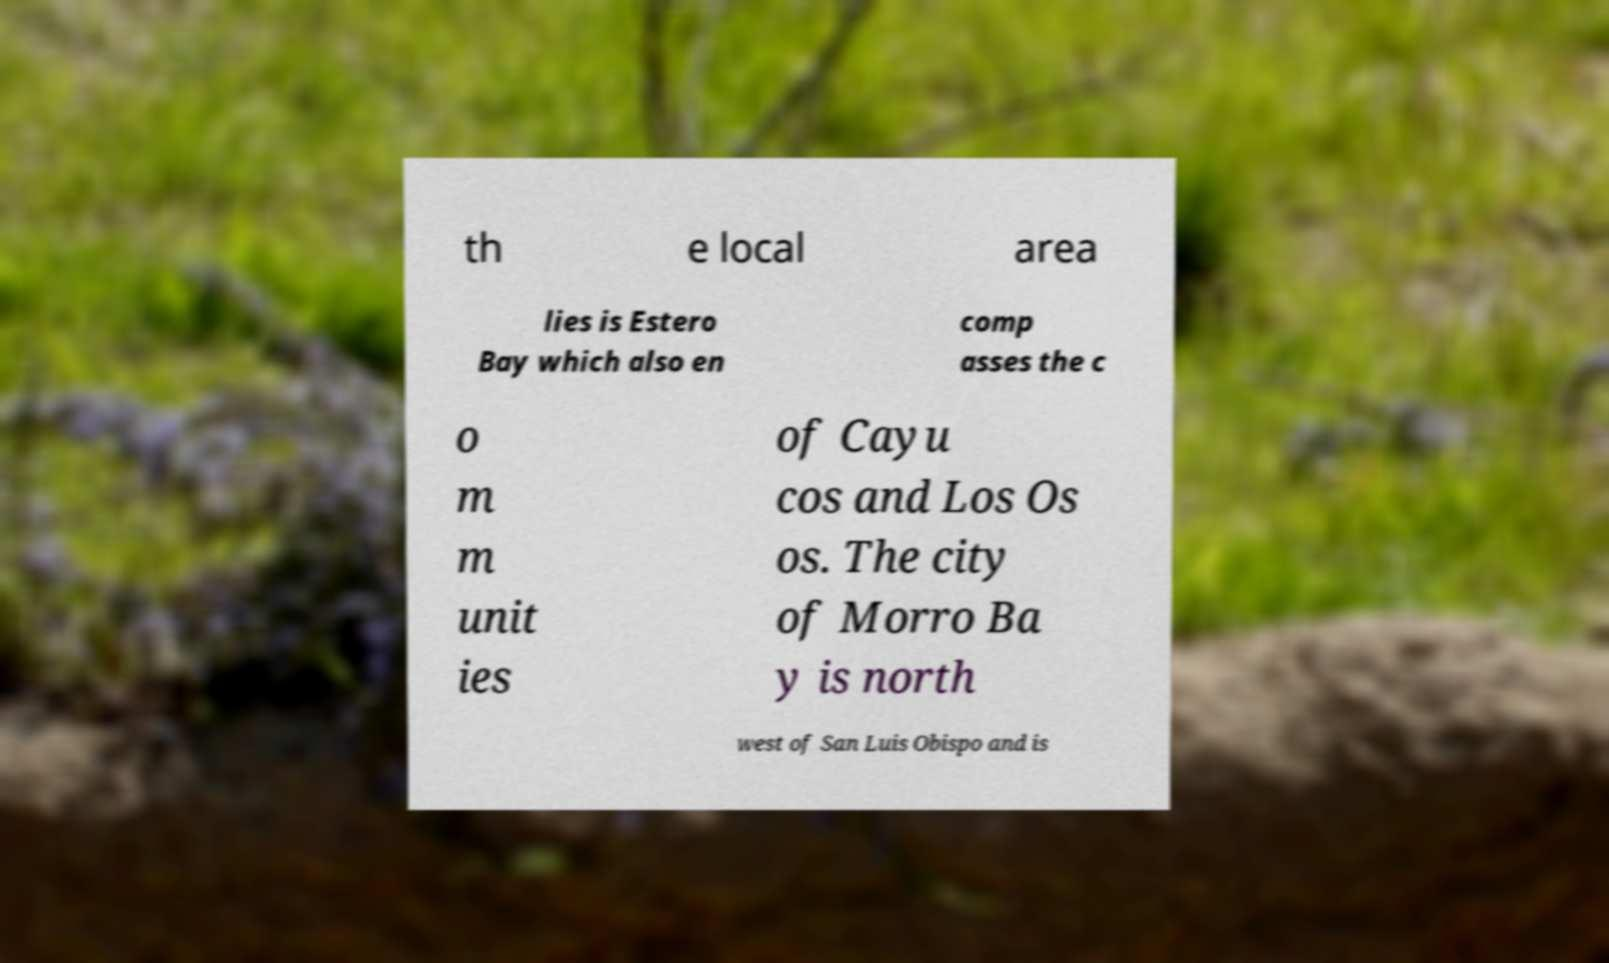What messages or text are displayed in this image? I need them in a readable, typed format. th e local area lies is Estero Bay which also en comp asses the c o m m unit ies of Cayu cos and Los Os os. The city of Morro Ba y is north west of San Luis Obispo and is 